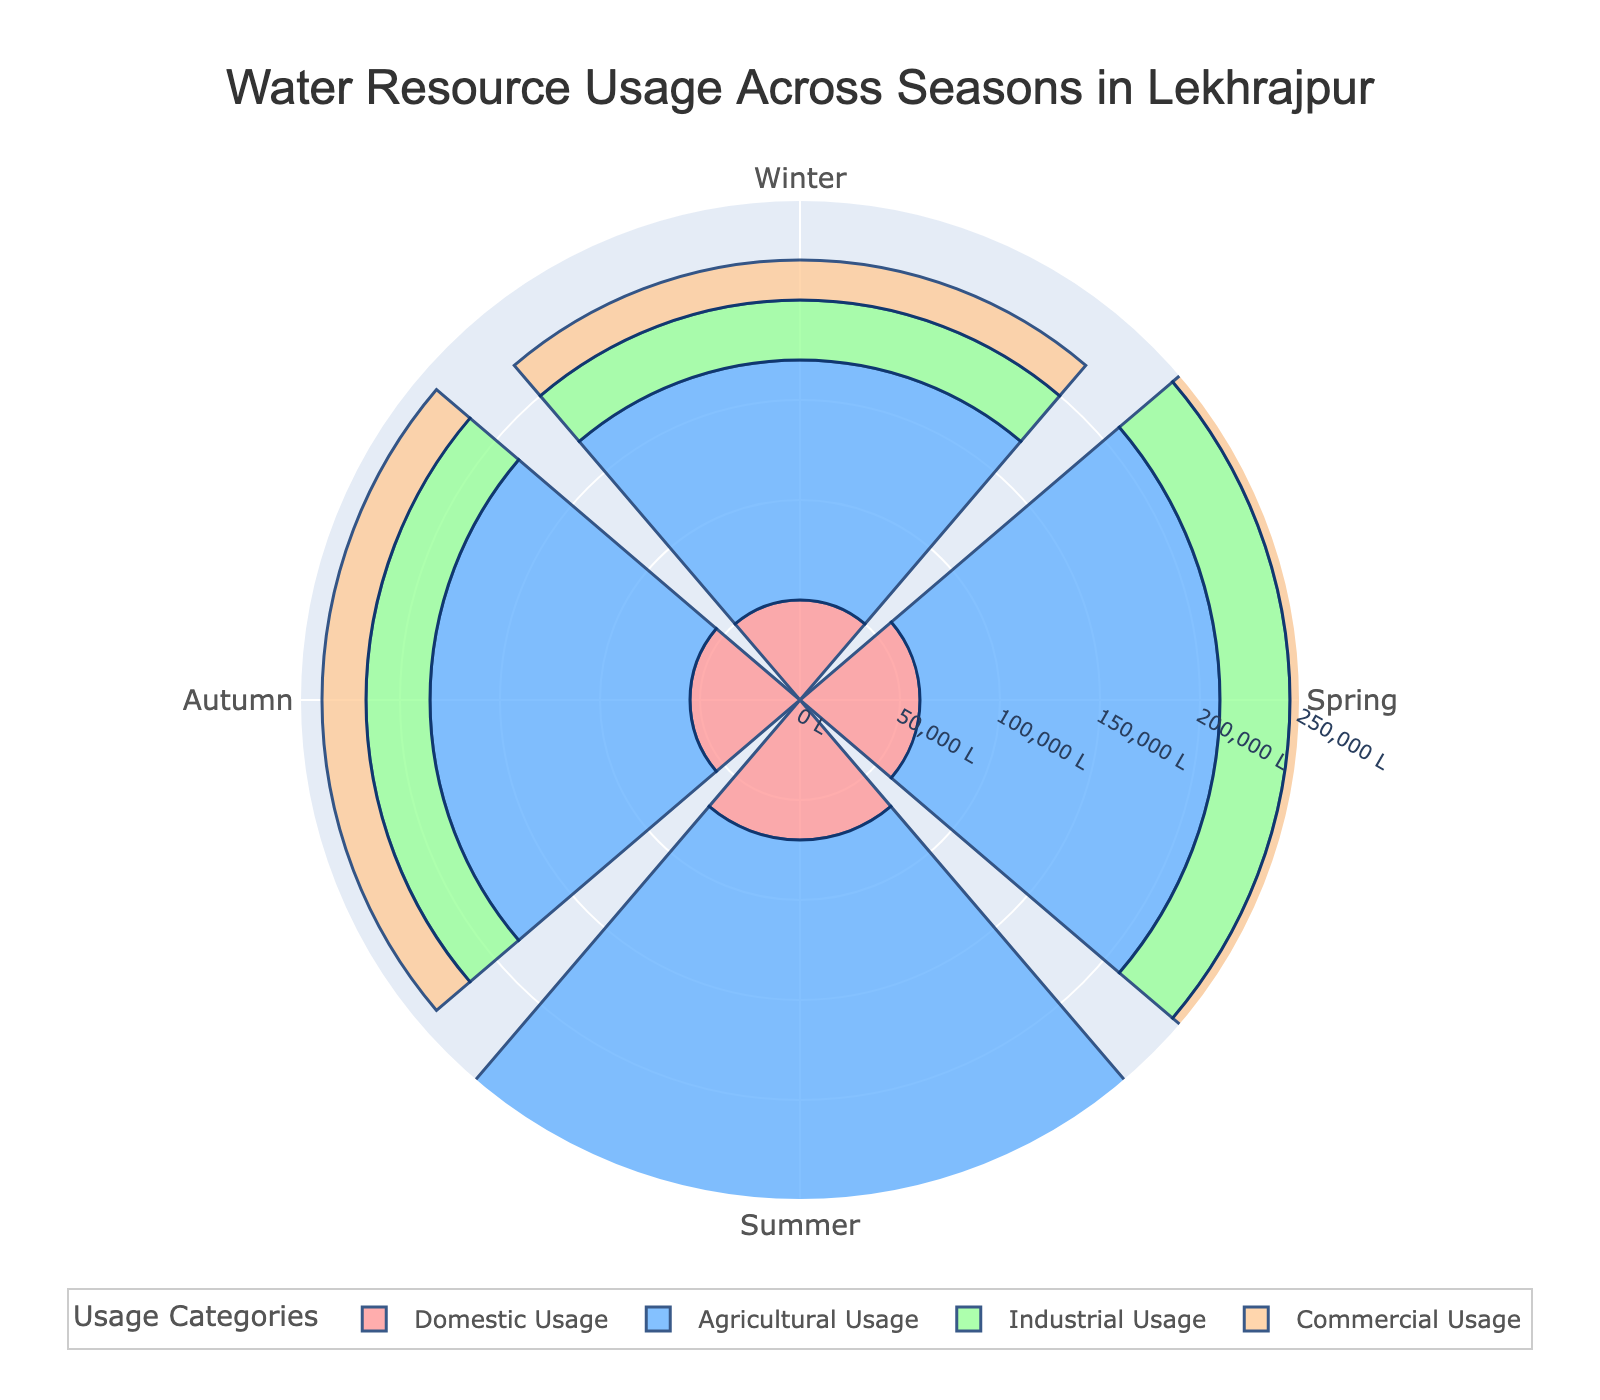What is the title of the figure? The title of the figure is displayed at the top and it summarizes the main content being shown in the chart. By looking there, we can see the title.
Answer: Water Resource Usage Across Seasons in Lekhrajpur How many categories of water usage are shown in the chart? We can count the different names listed in the legend, which categorize the water usage types.
Answer: Four What season has the highest agricultural water usage? By examining the lengths of the agricultural bars in the different seasons on the rose chart, we can find the highest bar which represents the greatest usage.
Answer: Summer Which season sees the least industrial water usage? By comparing the lengths of the bars labeled "Industrial Usage" across all seasons, the shortest bar indicates the season with the least industrial usage.
Answer: Winter What is the approximate difference in industrial water usage between summer and winter? Locate the lengths of the "Industrial Usage" bars for summer and winter, then calculate the difference between these values (40000 - 30000).
Answer: 10000 liters Summing up the domestic and commercial usage during spring, what's the total water usage? Add the domestic and commercial water usage amounts for spring: 60000 + 25000.
Answer: 85000 liters How does commercial water usage in autumn compare with that in spring? Compare the lengths of the "Commercial Usage" bars for autumn and spring.
Answer: Autumn usage is less by 3000 liters By what percentage does agricultural usage increase from winter to summer? Calculate the increase from winter (120000) to summer (200000), then the percentage increase: ((200000 - 120000) / 120000) * 100.
Answer: ~66.67% What is the average domestic water usage across the seasons? Sum the domestic usages for all seasons and divide by the number of seasons: (50000 + 60000 + 70000 + 55000) / 4.
Answer: 58750 liters Which season shows the most balanced distribution of water usage among all categories? Check the seasons and see which has the most similar lengths among all categories.
Answer: Autumn 